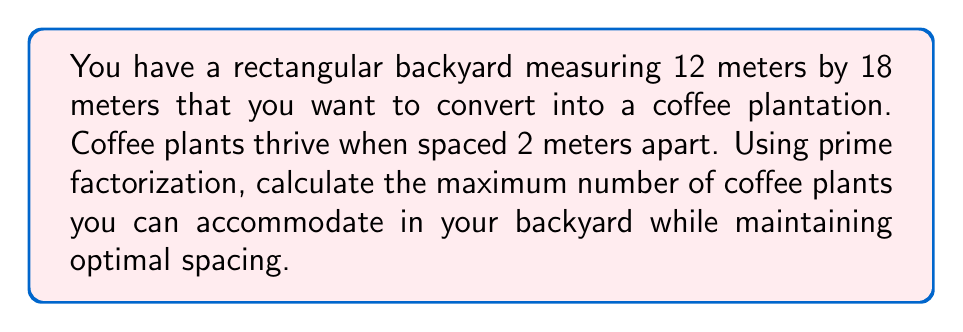Can you answer this question? To solve this problem, we'll follow these steps:

1) First, calculate the total area of the backyard:
   $$ \text{Area} = 12 \text{ m} \times 18 \text{ m} = 216 \text{ m}^2 $$

2) Each coffee plant needs a 2m x 2m space, so the area per plant is:
   $$ \text{Area per plant} = 2 \text{ m} \times 2 \text{ m} = 4 \text{ m}^2 $$

3) To find the maximum number of plants, divide the total area by the area per plant:
   $$ \text{Maximum plants} = \frac{216 \text{ m}^2}{4 \text{ m}^2} = 54 $$

4) Now, let's use prime factorization to verify this result:
   $$ 54 = 2 \times 3^3 $$

5) This factorization corresponds to the dimensions of our backyard:
   $$ 12 = 2^2 \times 3 $$
   $$ 18 = 2 \times 3^2 $$

6) The number of plants along each dimension:
   - Along 12m: $12 \div 2 = 6$ plants
   - Along 18m: $18 \div 2 = 9$ plants

7) Multiplying these:
   $$ 6 \times 9 = 54 \text{ plants} $$

This confirms our initial calculation and shows how the prime factorization relates to the physical layout of the plants.
Answer: 54 plants 